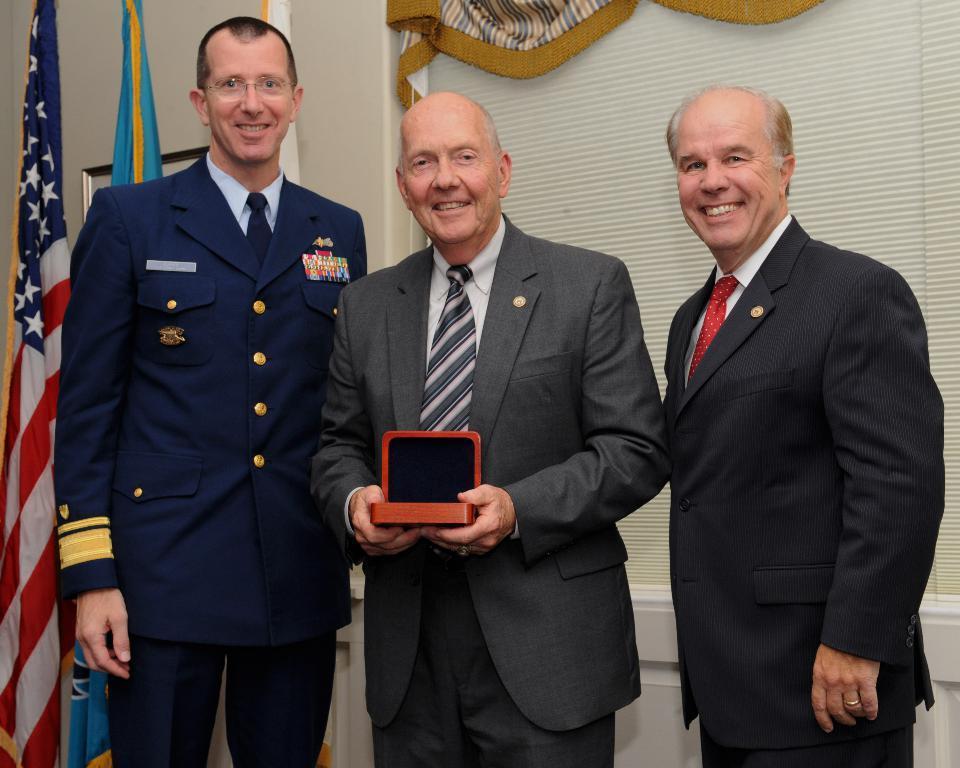How would you summarize this image in a sentence or two? In this picture we can see three men standing and smiling. We can see a man wearing grey suit is holding a box in his hand. There are flags on the left side. A frame is visible on the wall. We can see a cloth in the background. 